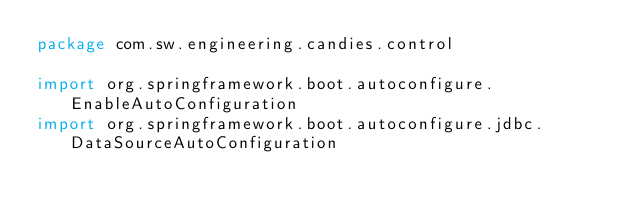Convert code to text. <code><loc_0><loc_0><loc_500><loc_500><_Kotlin_>package com.sw.engineering.candies.control

import org.springframework.boot.autoconfigure.EnableAutoConfiguration
import org.springframework.boot.autoconfigure.jdbc.DataSourceAutoConfiguration</code> 